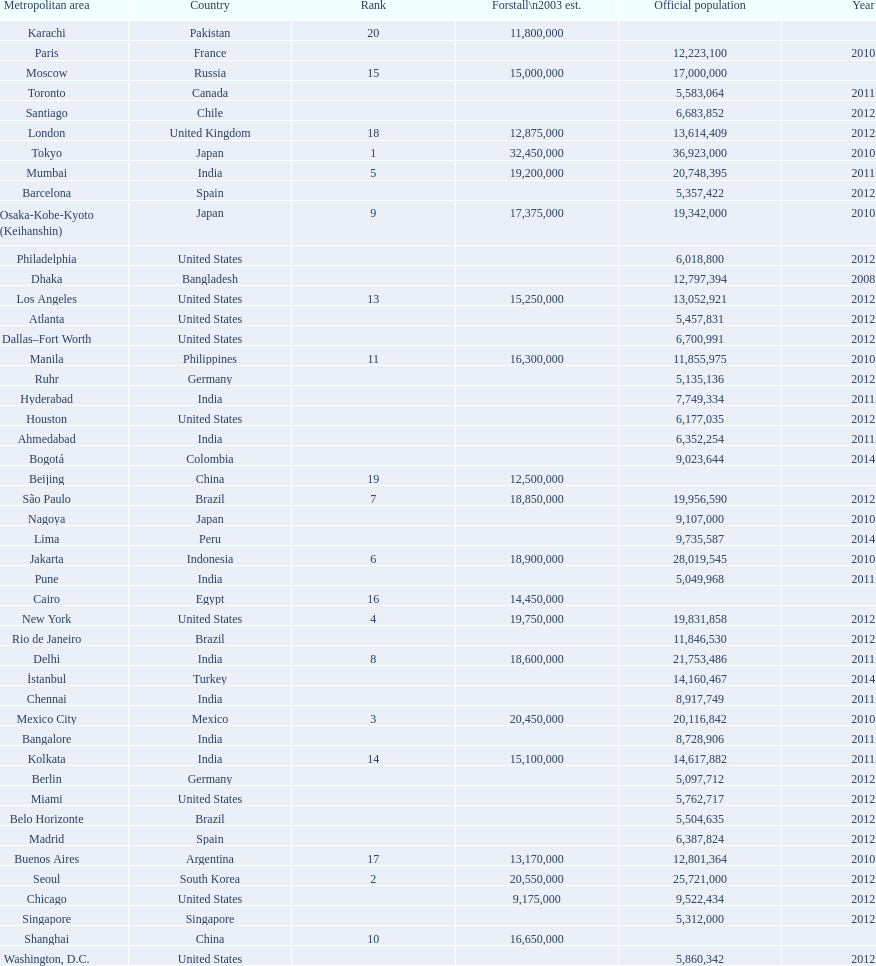Help me parse the entirety of this table. {'header': ['Metropolitan area', 'Country', 'Rank', 'Forstall\\n2003 est.', 'Official population', 'Year'], 'rows': [['Karachi', 'Pakistan', '20', '11,800,000', '', ''], ['Paris', 'France', '', '', '12,223,100', '2010'], ['Moscow', 'Russia', '15', '15,000,000', '17,000,000', ''], ['Toronto', 'Canada', '', '', '5,583,064', '2011'], ['Santiago', 'Chile', '', '', '6,683,852', '2012'], ['London', 'United Kingdom', '18', '12,875,000', '13,614,409', '2012'], ['Tokyo', 'Japan', '1', '32,450,000', '36,923,000', '2010'], ['Mumbai', 'India', '5', '19,200,000', '20,748,395', '2011'], ['Barcelona', 'Spain', '', '', '5,357,422', '2012'], ['Osaka-Kobe-Kyoto (Keihanshin)', 'Japan', '9', '17,375,000', '19,342,000', '2010'], ['Philadelphia', 'United States', '', '', '6,018,800', '2012'], ['Dhaka', 'Bangladesh', '', '', '12,797,394', '2008'], ['Los Angeles', 'United States', '13', '15,250,000', '13,052,921', '2012'], ['Atlanta', 'United States', '', '', '5,457,831', '2012'], ['Dallas–Fort Worth', 'United States', '', '', '6,700,991', '2012'], ['Manila', 'Philippines', '11', '16,300,000', '11,855,975', '2010'], ['Ruhr', 'Germany', '', '', '5,135,136', '2012'], ['Hyderabad', 'India', '', '', '7,749,334', '2011'], ['Houston', 'United States', '', '', '6,177,035', '2012'], ['Ahmedabad', 'India', '', '', '6,352,254', '2011'], ['Bogotá', 'Colombia', '', '', '9,023,644', '2014'], ['Beijing', 'China', '19', '12,500,000', '', ''], ['São Paulo', 'Brazil', '7', '18,850,000', '19,956,590', '2012'], ['Nagoya', 'Japan', '', '', '9,107,000', '2010'], ['Lima', 'Peru', '', '', '9,735,587', '2014'], ['Jakarta', 'Indonesia', '6', '18,900,000', '28,019,545', '2010'], ['Pune', 'India', '', '', '5,049,968', '2011'], ['Cairo', 'Egypt', '16', '14,450,000', '', ''], ['New York', 'United States', '4', '19,750,000', '19,831,858', '2012'], ['Rio de Janeiro', 'Brazil', '', '', '11,846,530', '2012'], ['Delhi', 'India', '8', '18,600,000', '21,753,486', '2011'], ['İstanbul', 'Turkey', '', '', '14,160,467', '2014'], ['Chennai', 'India', '', '', '8,917,749', '2011'], ['Mexico City', 'Mexico', '3', '20,450,000', '20,116,842', '2010'], ['Bangalore', 'India', '', '', '8,728,906', '2011'], ['Kolkata', 'India', '14', '15,100,000', '14,617,882', '2011'], ['Berlin', 'Germany', '', '', '5,097,712', '2012'], ['Miami', 'United States', '', '', '5,762,717', '2012'], ['Belo Horizonte', 'Brazil', '', '', '5,504,635', '2012'], ['Madrid', 'Spain', '', '', '6,387,824', '2012'], ['Buenos Aires', 'Argentina', '17', '13,170,000', '12,801,364', '2010'], ['Seoul', 'South Korea', '2', '20,550,000', '25,721,000', '2012'], ['Chicago', 'United States', '', '9,175,000', '9,522,434', '2012'], ['Singapore', 'Singapore', '', '', '5,312,000', '2012'], ['Shanghai', 'China', '10', '16,650,000', '', ''], ['Washington, D.C.', 'United States', '', '', '5,860,342', '2012']]} Which areas had a population of more than 10,000,000 but less than 20,000,000? Buenos Aires, Dhaka, İstanbul, Kolkata, London, Los Angeles, Manila, Moscow, New York, Osaka-Kobe-Kyoto (Keihanshin), Paris, Rio de Janeiro, São Paulo. 